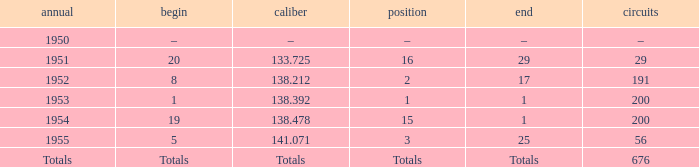What ranking that had a start of 19? 15.0. 